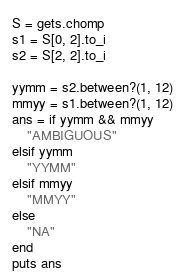<code> <loc_0><loc_0><loc_500><loc_500><_Ruby_>S = gets.chomp
s1 = S[0, 2].to_i
s2 = S[2, 2].to_i

yymm = s2.between?(1, 12)
mmyy = s1.between?(1, 12)
ans = if yymm && mmyy
    "AMBIGUOUS"
elsif yymm
    "YYMM"
elsif mmyy
    "MMYY"
else
    "NA"
end
puts ans</code> 